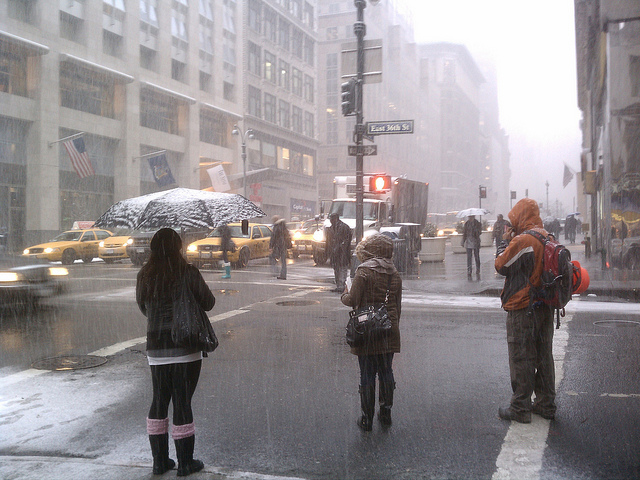Please transcribe the text information in this image. H 